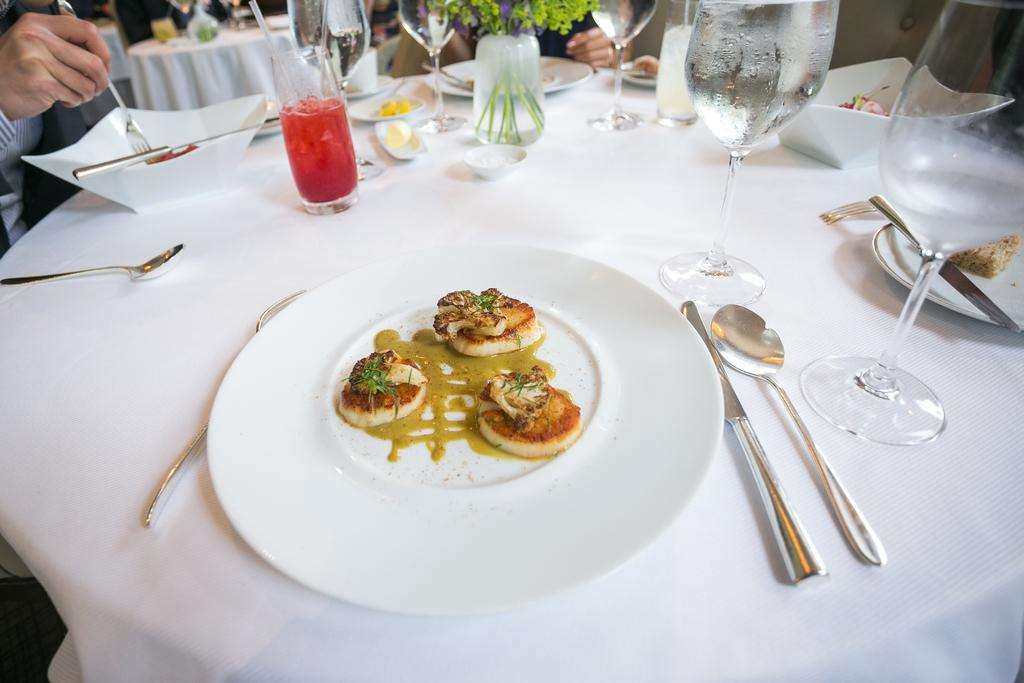What piece of furniture is present in the image? There is a table in the image. What is covering the table? The table is covered with a cloth. What items are on the table? There is a plate, a glass, and spoons on the table. What type of canvas is being used to paint a portrait of the brother in the image? There is no canvas or brother present in the image; it only features a table with a cloth, a plate, a glass, and spoons. 